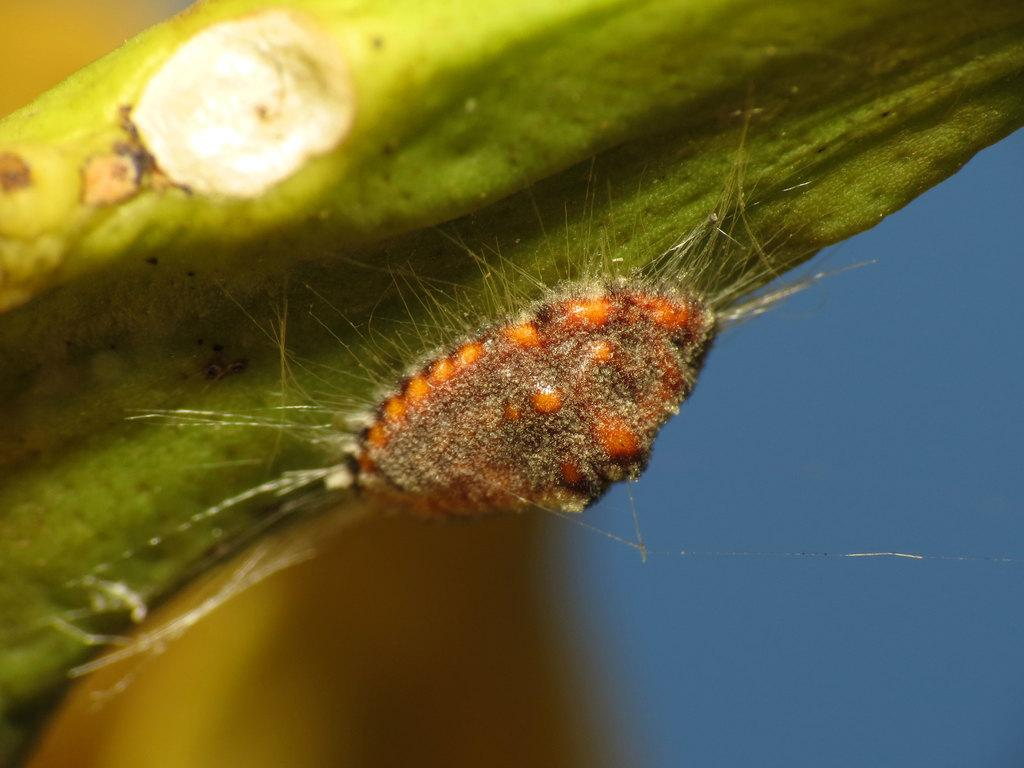What type of creature is present in the image? There is an insect in the image. What colors can be seen on the insect? The insect has orange and brown colors. What is the insect resting on in the image? The insect is on a green object. What color is the background of the image? The background of the image is blue. What type of attraction can be seen in the image? There is no attraction present in the image; it features an insect on a green object with a blue background. 